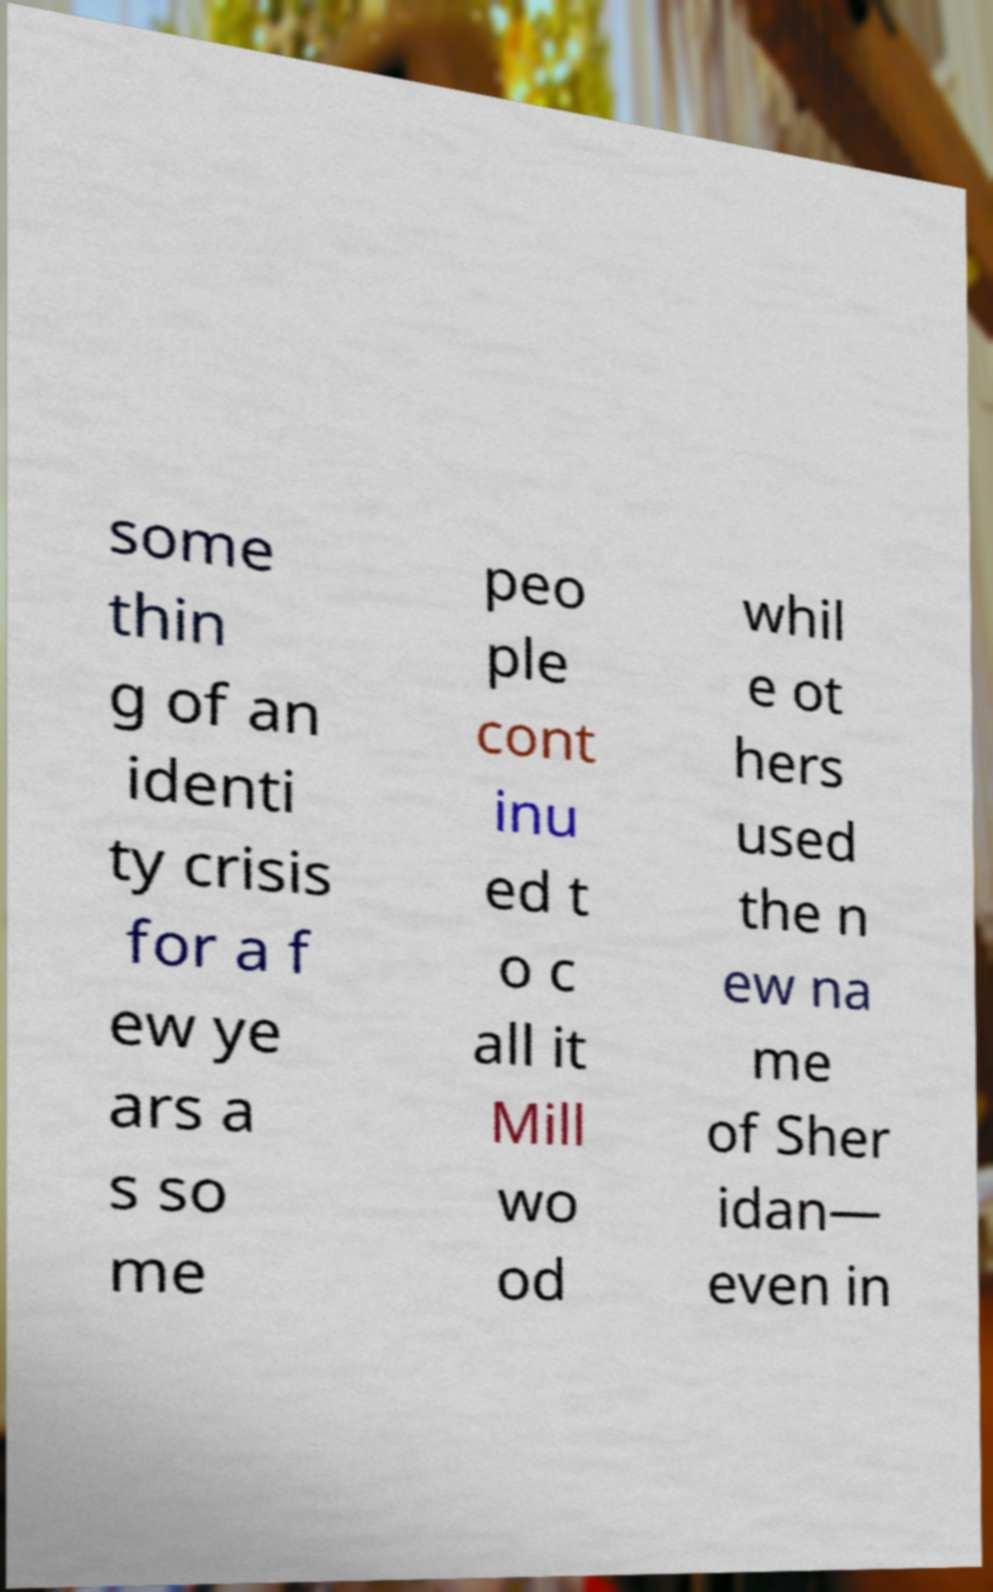Please read and relay the text visible in this image. What does it say? some thin g of an identi ty crisis for a f ew ye ars a s so me peo ple cont inu ed t o c all it Mill wo od whil e ot hers used the n ew na me of Sher idan— even in 